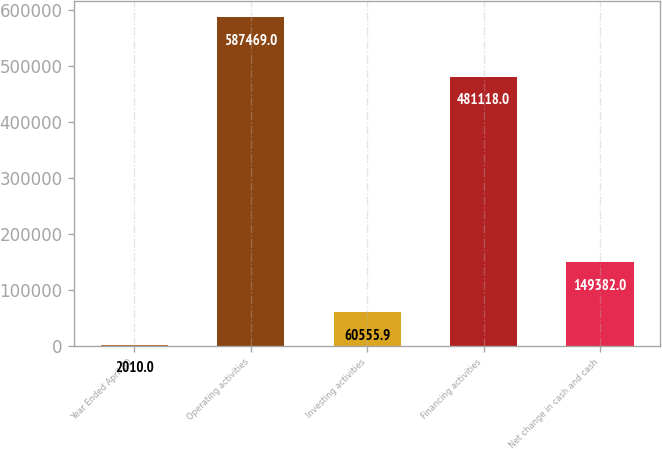Convert chart to OTSL. <chart><loc_0><loc_0><loc_500><loc_500><bar_chart><fcel>Year Ended April 30<fcel>Operating activities<fcel>Investing activities<fcel>Financing activities<fcel>Net change in cash and cash<nl><fcel>2010<fcel>587469<fcel>60555.9<fcel>481118<fcel>149382<nl></chart> 